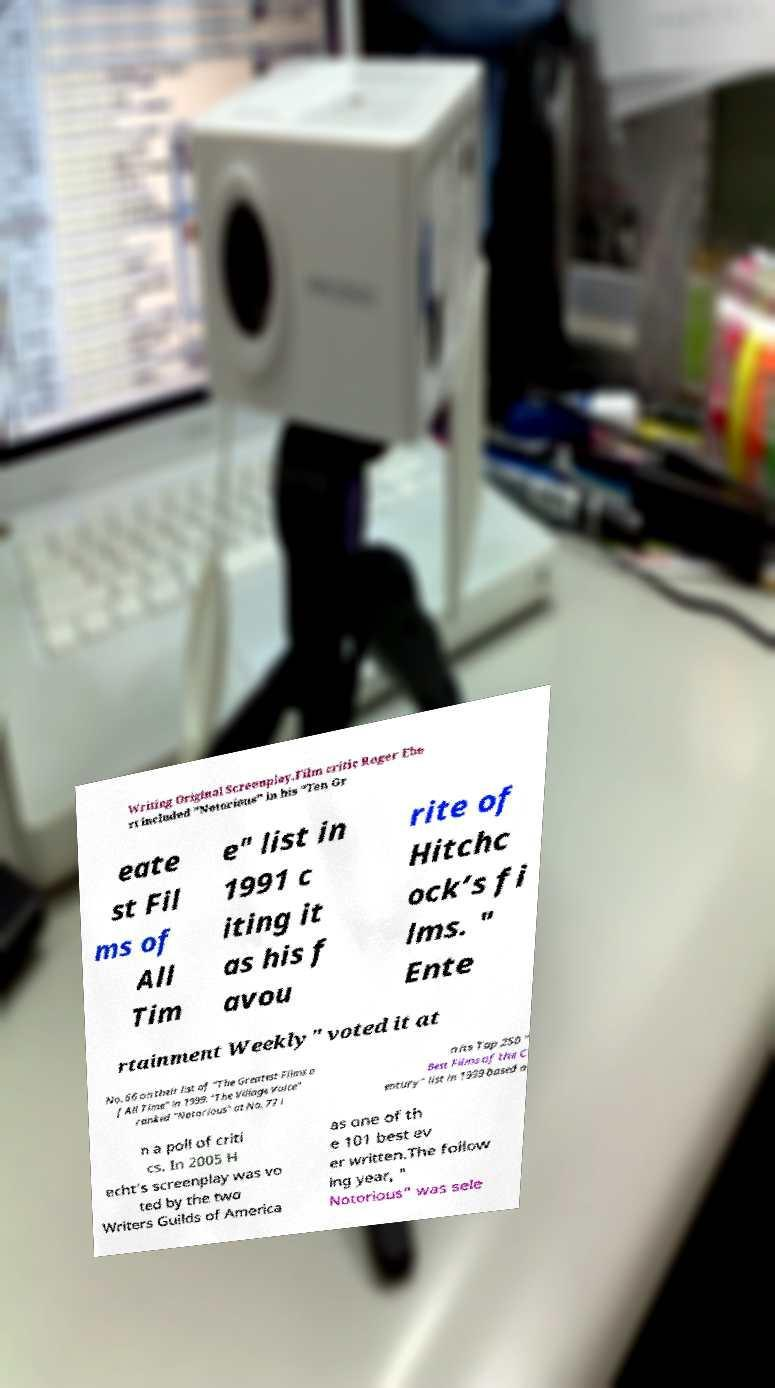For documentation purposes, I need the text within this image transcribed. Could you provide that? Writing Original Screenplay.Film critic Roger Ebe rt included "Notorious" in his "Ten Gr eate st Fil ms of All Tim e" list in 1991 c iting it as his f avou rite of Hitchc ock’s fi lms. " Ente rtainment Weekly" voted it at No. 66 on their list of "The Greatest Films o f All Time" in 1999. "The Village Voice" ranked "Notorious" at No. 77 i n its Top 250 " Best Films of the C entury" list in 1999 based o n a poll of criti cs. In 2005 H echt's screenplay was vo ted by the two Writers Guilds of America as one of th e 101 best ev er written.The follow ing year, " Notorious" was sele 